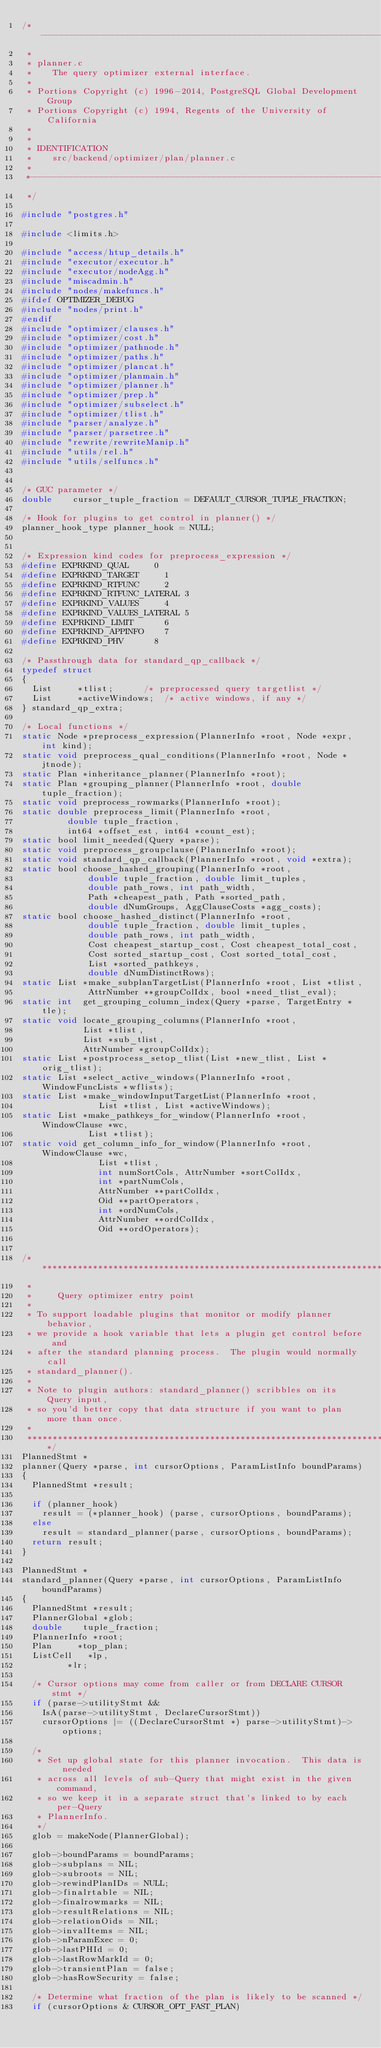<code> <loc_0><loc_0><loc_500><loc_500><_C_>/*-------------------------------------------------------------------------
 *
 * planner.c
 *	  The query optimizer external interface.
 *
 * Portions Copyright (c) 1996-2014, PostgreSQL Global Development Group
 * Portions Copyright (c) 1994, Regents of the University of California
 *
 *
 * IDENTIFICATION
 *	  src/backend/optimizer/plan/planner.c
 *
 *-------------------------------------------------------------------------
 */

#include "postgres.h"

#include <limits.h>

#include "access/htup_details.h"
#include "executor/executor.h"
#include "executor/nodeAgg.h"
#include "miscadmin.h"
#include "nodes/makefuncs.h"
#ifdef OPTIMIZER_DEBUG
#include "nodes/print.h"
#endif
#include "optimizer/clauses.h"
#include "optimizer/cost.h"
#include "optimizer/pathnode.h"
#include "optimizer/paths.h"
#include "optimizer/plancat.h"
#include "optimizer/planmain.h"
#include "optimizer/planner.h"
#include "optimizer/prep.h"
#include "optimizer/subselect.h"
#include "optimizer/tlist.h"
#include "parser/analyze.h"
#include "parser/parsetree.h"
#include "rewrite/rewriteManip.h"
#include "utils/rel.h"
#include "utils/selfuncs.h"


/* GUC parameter */
double		cursor_tuple_fraction = DEFAULT_CURSOR_TUPLE_FRACTION;

/* Hook for plugins to get control in planner() */
planner_hook_type planner_hook = NULL;


/* Expression kind codes for preprocess_expression */
#define EXPRKIND_QUAL			0
#define EXPRKIND_TARGET			1
#define EXPRKIND_RTFUNC			2
#define EXPRKIND_RTFUNC_LATERAL 3
#define EXPRKIND_VALUES			4
#define EXPRKIND_VALUES_LATERAL 5
#define EXPRKIND_LIMIT			6
#define EXPRKIND_APPINFO		7
#define EXPRKIND_PHV			8

/* Passthrough data for standard_qp_callback */
typedef struct
{
	List	   *tlist;			/* preprocessed query targetlist */
	List	   *activeWindows;	/* active windows, if any */
} standard_qp_extra;

/* Local functions */
static Node *preprocess_expression(PlannerInfo *root, Node *expr, int kind);
static void preprocess_qual_conditions(PlannerInfo *root, Node *jtnode);
static Plan *inheritance_planner(PlannerInfo *root);
static Plan *grouping_planner(PlannerInfo *root, double tuple_fraction);
static void preprocess_rowmarks(PlannerInfo *root);
static double preprocess_limit(PlannerInfo *root,
				 double tuple_fraction,
				 int64 *offset_est, int64 *count_est);
static bool limit_needed(Query *parse);
static void preprocess_groupclause(PlannerInfo *root);
static void standard_qp_callback(PlannerInfo *root, void *extra);
static bool choose_hashed_grouping(PlannerInfo *root,
					   double tuple_fraction, double limit_tuples,
					   double path_rows, int path_width,
					   Path *cheapest_path, Path *sorted_path,
					   double dNumGroups, AggClauseCosts *agg_costs);
static bool choose_hashed_distinct(PlannerInfo *root,
					   double tuple_fraction, double limit_tuples,
					   double path_rows, int path_width,
					   Cost cheapest_startup_cost, Cost cheapest_total_cost,
					   Cost sorted_startup_cost, Cost sorted_total_cost,
					   List *sorted_pathkeys,
					   double dNumDistinctRows);
static List *make_subplanTargetList(PlannerInfo *root, List *tlist,
					   AttrNumber **groupColIdx, bool *need_tlist_eval);
static int	get_grouping_column_index(Query *parse, TargetEntry *tle);
static void locate_grouping_columns(PlannerInfo *root,
						List *tlist,
						List *sub_tlist,
						AttrNumber *groupColIdx);
static List *postprocess_setop_tlist(List *new_tlist, List *orig_tlist);
static List *select_active_windows(PlannerInfo *root, WindowFuncLists *wflists);
static List *make_windowInputTargetList(PlannerInfo *root,
						   List *tlist, List *activeWindows);
static List *make_pathkeys_for_window(PlannerInfo *root, WindowClause *wc,
						 List *tlist);
static void get_column_info_for_window(PlannerInfo *root, WindowClause *wc,
						   List *tlist,
						   int numSortCols, AttrNumber *sortColIdx,
						   int *partNumCols,
						   AttrNumber **partColIdx,
						   Oid **partOperators,
						   int *ordNumCols,
						   AttrNumber **ordColIdx,
						   Oid **ordOperators);


/*****************************************************************************
 *
 *	   Query optimizer entry point
 *
 * To support loadable plugins that monitor or modify planner behavior,
 * we provide a hook variable that lets a plugin get control before and
 * after the standard planning process.  The plugin would normally call
 * standard_planner().
 *
 * Note to plugin authors: standard_planner() scribbles on its Query input,
 * so you'd better copy that data structure if you want to plan more than once.
 *
 *****************************************************************************/
PlannedStmt *
planner(Query *parse, int cursorOptions, ParamListInfo boundParams)
{
	PlannedStmt *result;

	if (planner_hook)
		result = (*planner_hook) (parse, cursorOptions, boundParams);
	else
		result = standard_planner(parse, cursorOptions, boundParams);
	return result;
}

PlannedStmt *
standard_planner(Query *parse, int cursorOptions, ParamListInfo boundParams)
{
	PlannedStmt *result;
	PlannerGlobal *glob;
	double		tuple_fraction;
	PlannerInfo *root;
	Plan	   *top_plan;
	ListCell   *lp,
			   *lr;

	/* Cursor options may come from caller or from DECLARE CURSOR stmt */
	if (parse->utilityStmt &&
		IsA(parse->utilityStmt, DeclareCursorStmt))
		cursorOptions |= ((DeclareCursorStmt *) parse->utilityStmt)->options;

	/*
	 * Set up global state for this planner invocation.  This data is needed
	 * across all levels of sub-Query that might exist in the given command,
	 * so we keep it in a separate struct that's linked to by each per-Query
	 * PlannerInfo.
	 */
	glob = makeNode(PlannerGlobal);

	glob->boundParams = boundParams;
	glob->subplans = NIL;
	glob->subroots = NIL;
	glob->rewindPlanIDs = NULL;
	glob->finalrtable = NIL;
	glob->finalrowmarks = NIL;
	glob->resultRelations = NIL;
	glob->relationOids = NIL;
	glob->invalItems = NIL;
	glob->nParamExec = 0;
	glob->lastPHId = 0;
	glob->lastRowMarkId = 0;
	glob->transientPlan = false;
	glob->hasRowSecurity = false;

	/* Determine what fraction of the plan is likely to be scanned */
	if (cursorOptions & CURSOR_OPT_FAST_PLAN)</code> 